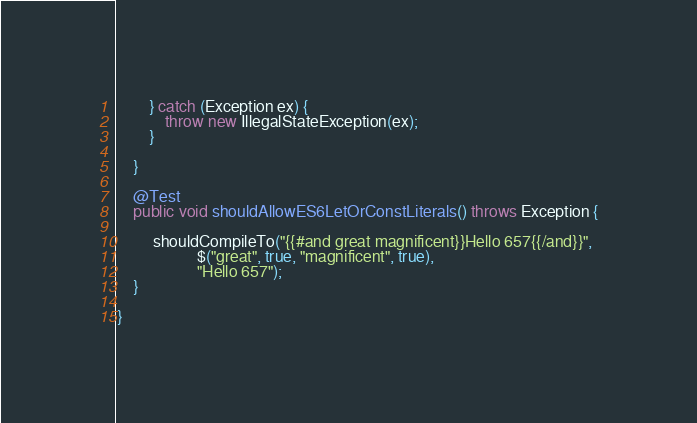Convert code to text. <code><loc_0><loc_0><loc_500><loc_500><_Java_>		} catch (Exception ex) {
			throw new IllegalStateException(ex);
		}
		
	}

	@Test
	public void shouldAllowES6LetOrConstLiterals() throws Exception {

		 shouldCompileTo("{{#and great magnificent}}Hello 657{{/and}}",
			        $("great", true, "magnificent", true),
			        "Hello 657");
	}

}
</code> 